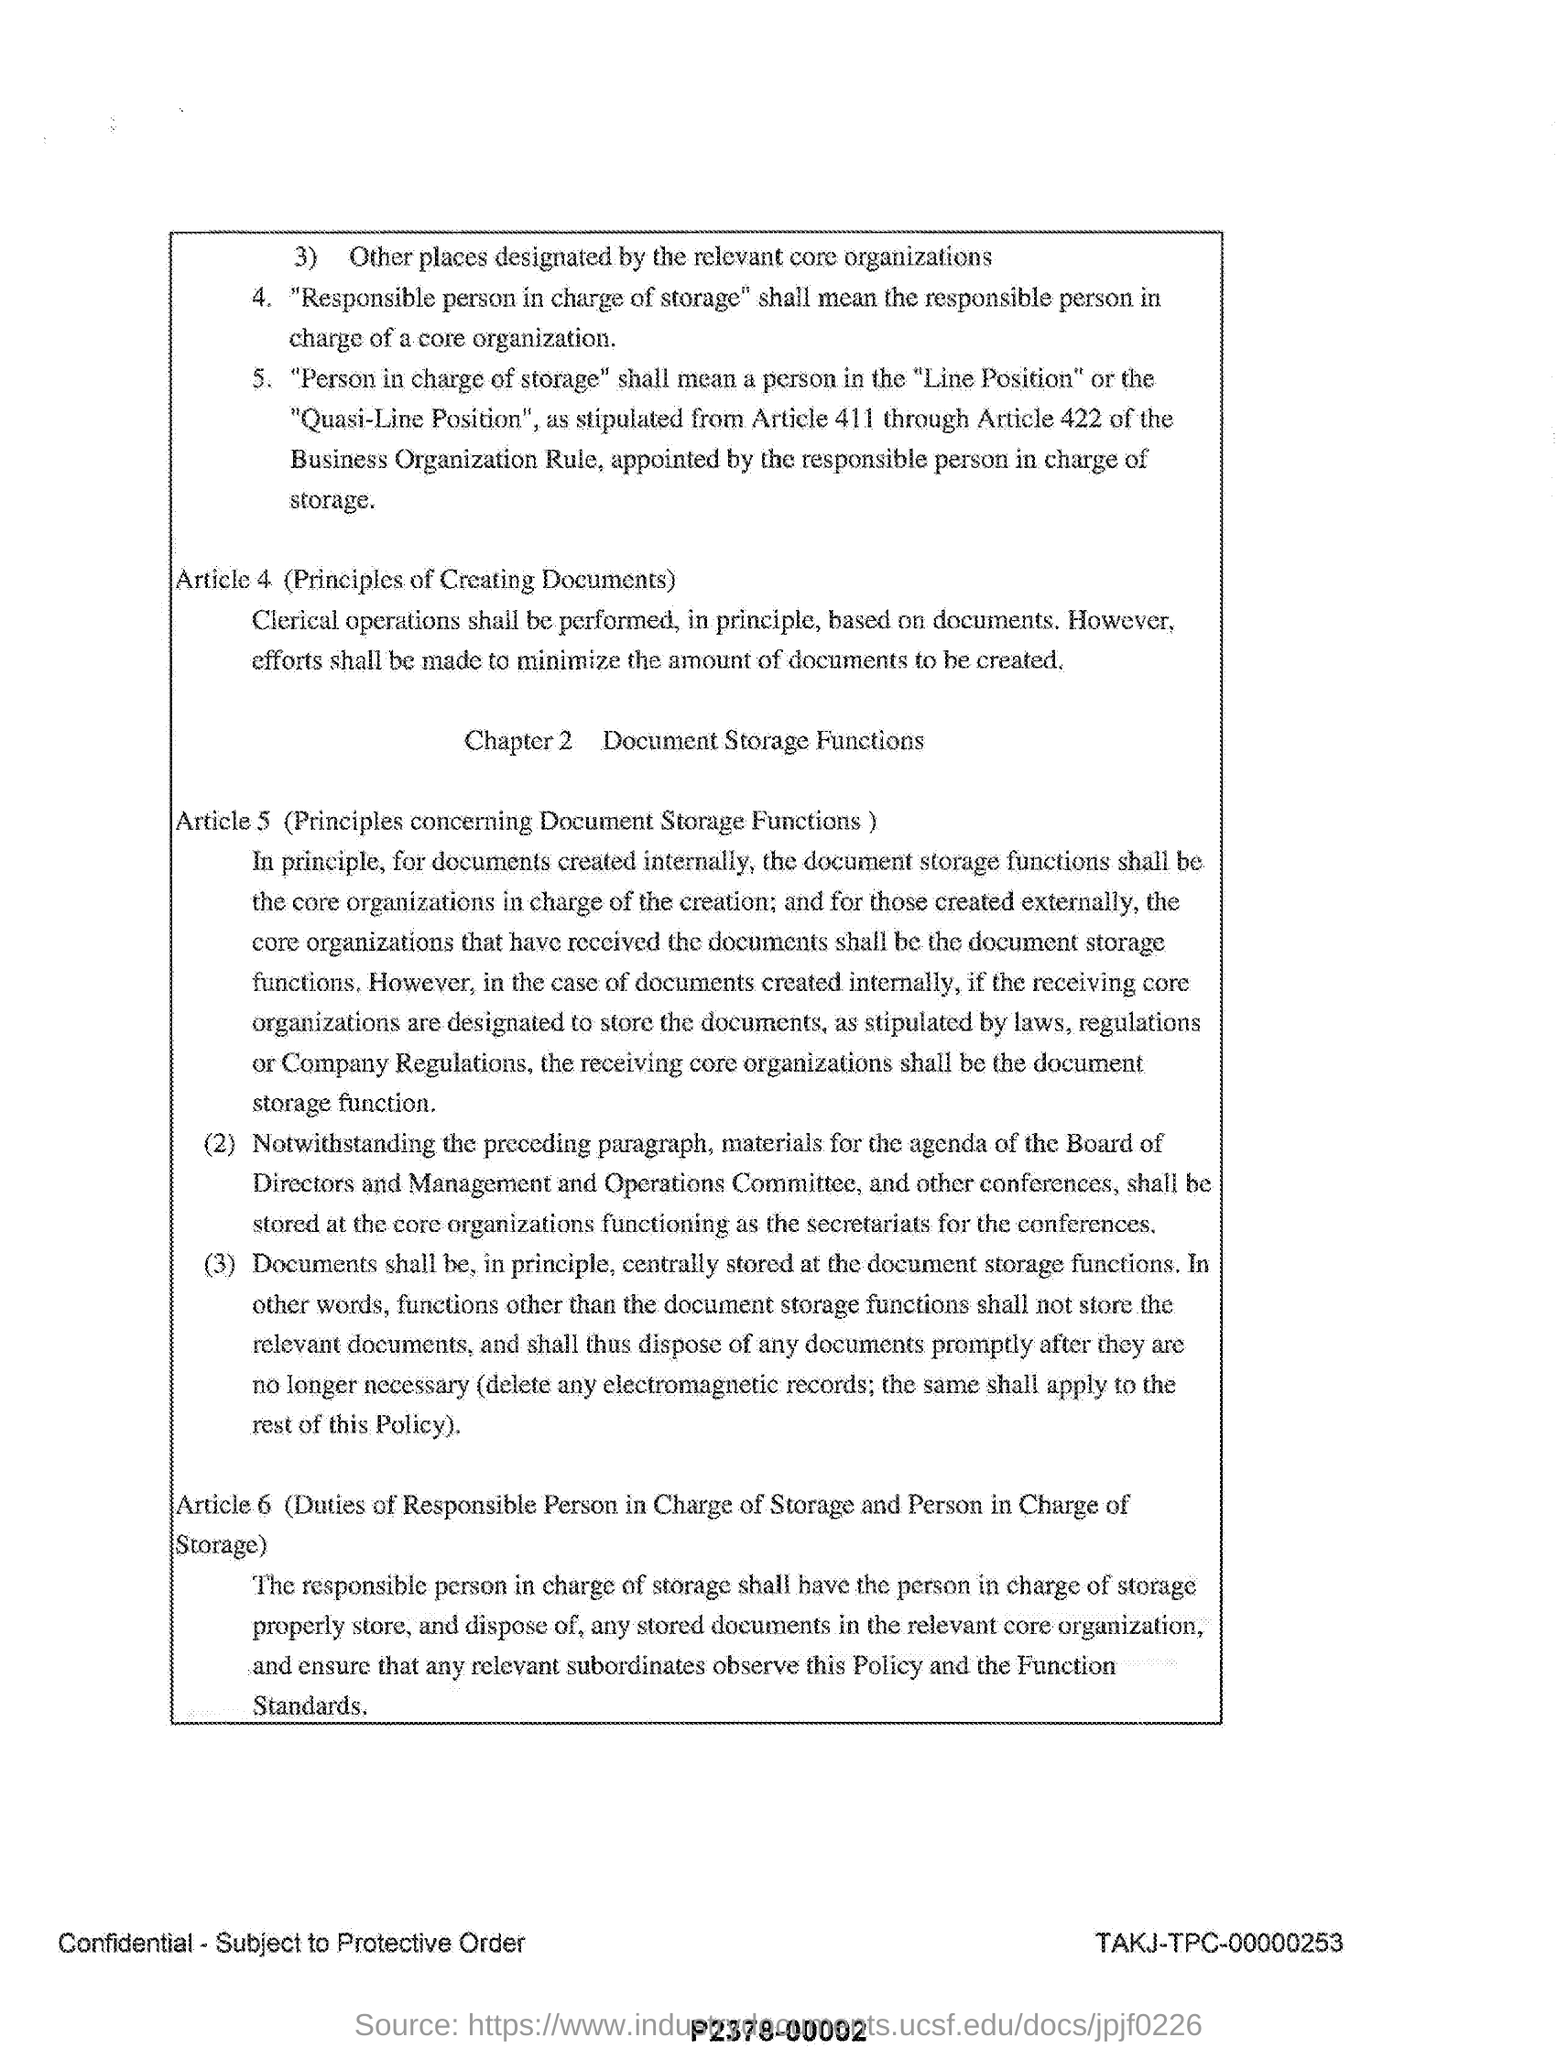What is article 4?
Provide a short and direct response. (PRINCIPLES OF CREATING DOCUMENTS). What is the title of chapter 2?
Ensure brevity in your answer.  Document storage functions. What does article 5 in this document describes?
Give a very brief answer. Principles concerning document storage functions. What is article 6?
Provide a short and direct response. Duties of responsible person in charge of storage and person in charge of storage. 